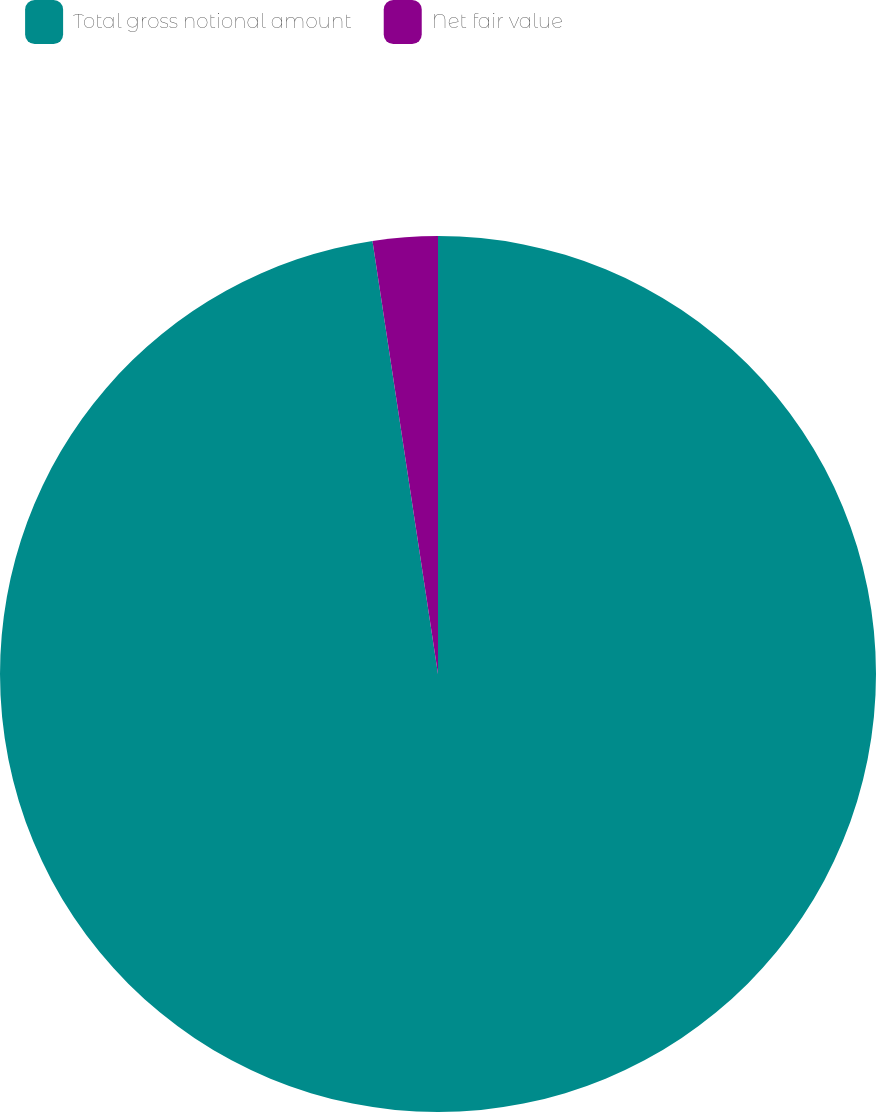Convert chart to OTSL. <chart><loc_0><loc_0><loc_500><loc_500><pie_chart><fcel>Total gross notional amount<fcel>Net fair value<nl><fcel>97.61%<fcel>2.39%<nl></chart> 